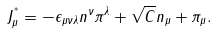Convert formula to latex. <formula><loc_0><loc_0><loc_500><loc_500>J ^ { ^ { * } } _ { \mu } = - \epsilon _ { \mu \nu \lambda } n ^ { \nu } \pi ^ { \lambda } + \sqrt { C } n _ { \mu } + \pi _ { \mu } .</formula> 